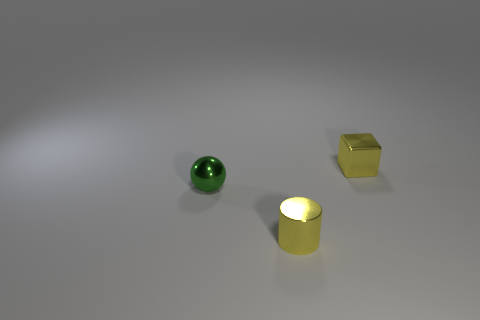Add 2 small green things. How many objects exist? 5 Subtract 1 cylinders. How many cylinders are left? 0 Subtract all brown blocks. How many yellow balls are left? 0 Subtract all tiny metal spheres. Subtract all cylinders. How many objects are left? 1 Add 2 green balls. How many green balls are left? 3 Add 1 cylinders. How many cylinders exist? 2 Subtract 0 red spheres. How many objects are left? 3 Subtract all cubes. How many objects are left? 2 Subtract all blue spheres. Subtract all purple cylinders. How many spheres are left? 1 